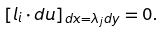Convert formula to latex. <formula><loc_0><loc_0><loc_500><loc_500>\left [ l _ { i } \cdot d u \right ] _ { d x = \lambda _ { j } d y } = 0 .</formula> 